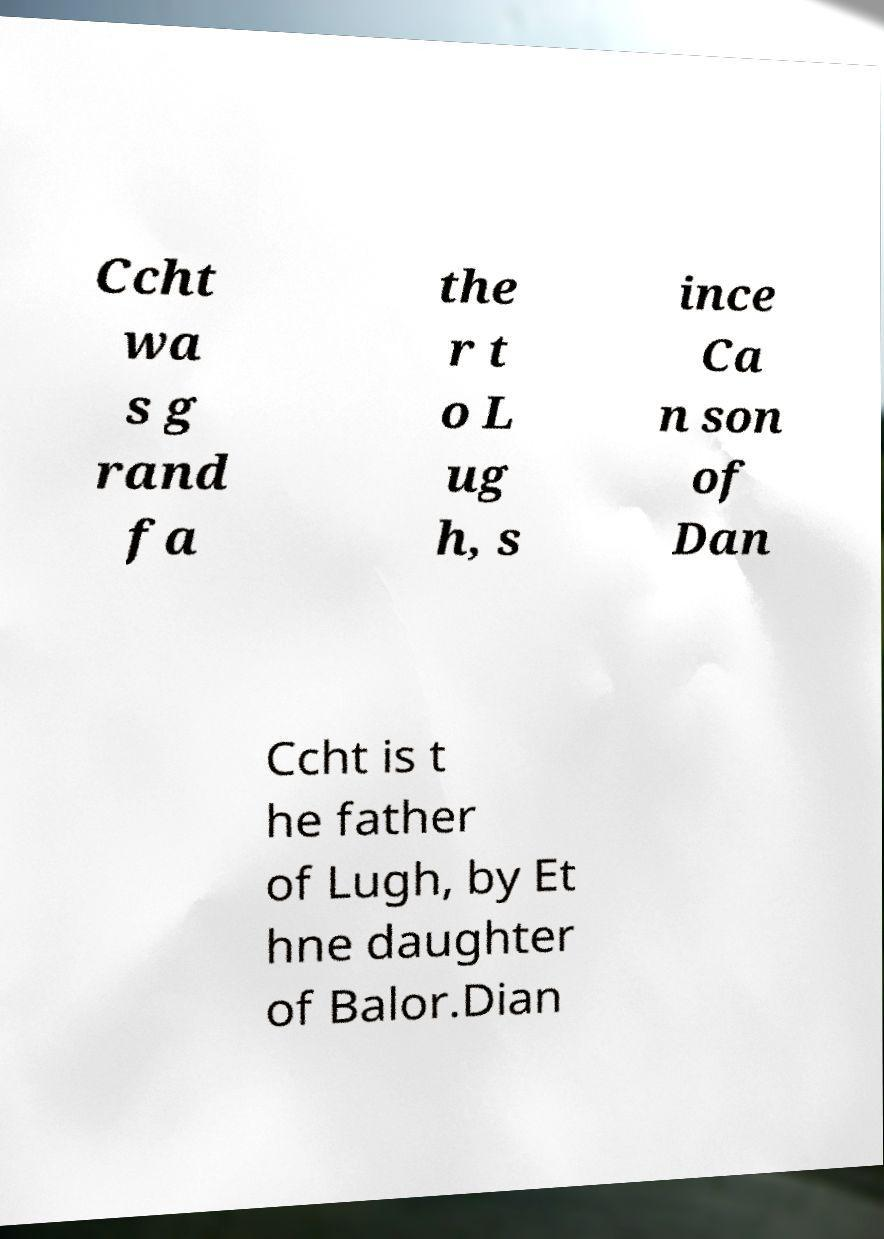Could you extract and type out the text from this image? Ccht wa s g rand fa the r t o L ug h, s ince Ca n son of Dan Ccht is t he father of Lugh, by Et hne daughter of Balor.Dian 